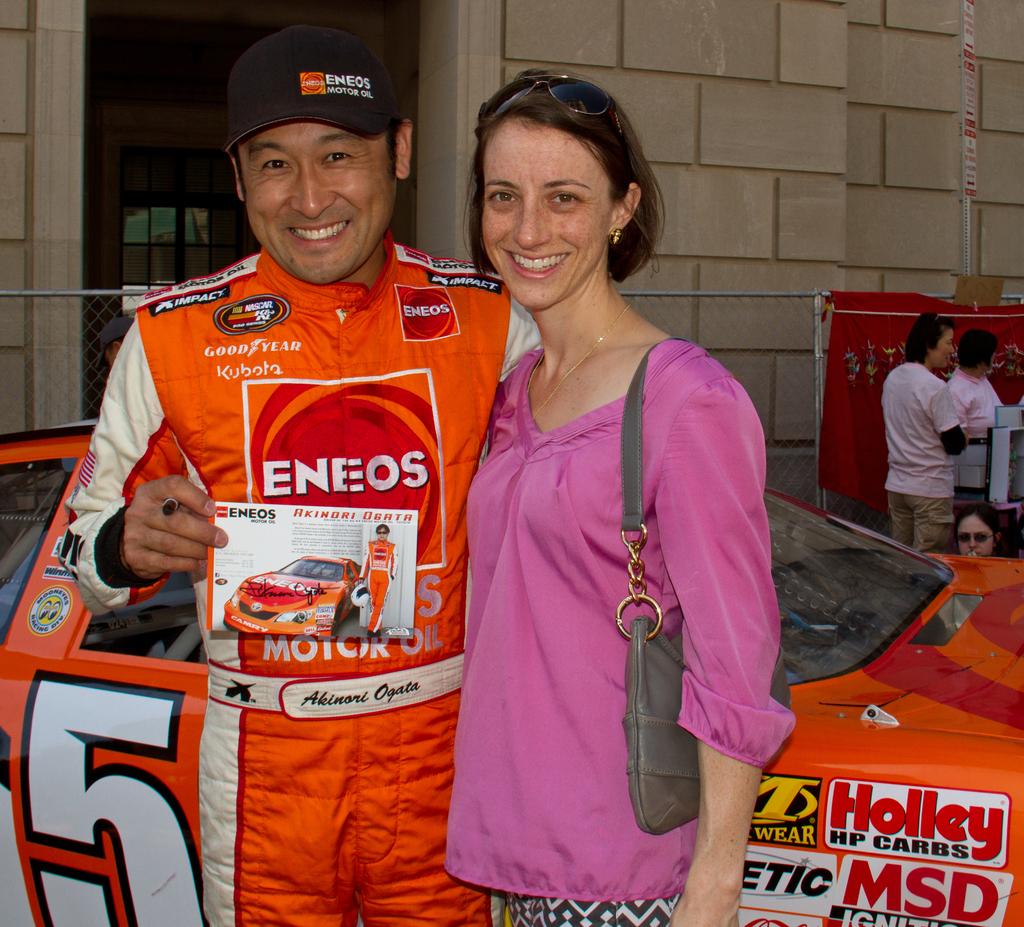Who is the main sponsor of the orange driver?
Give a very brief answer. Eneos. What number is on the bottom left?
Keep it short and to the point. 5. 